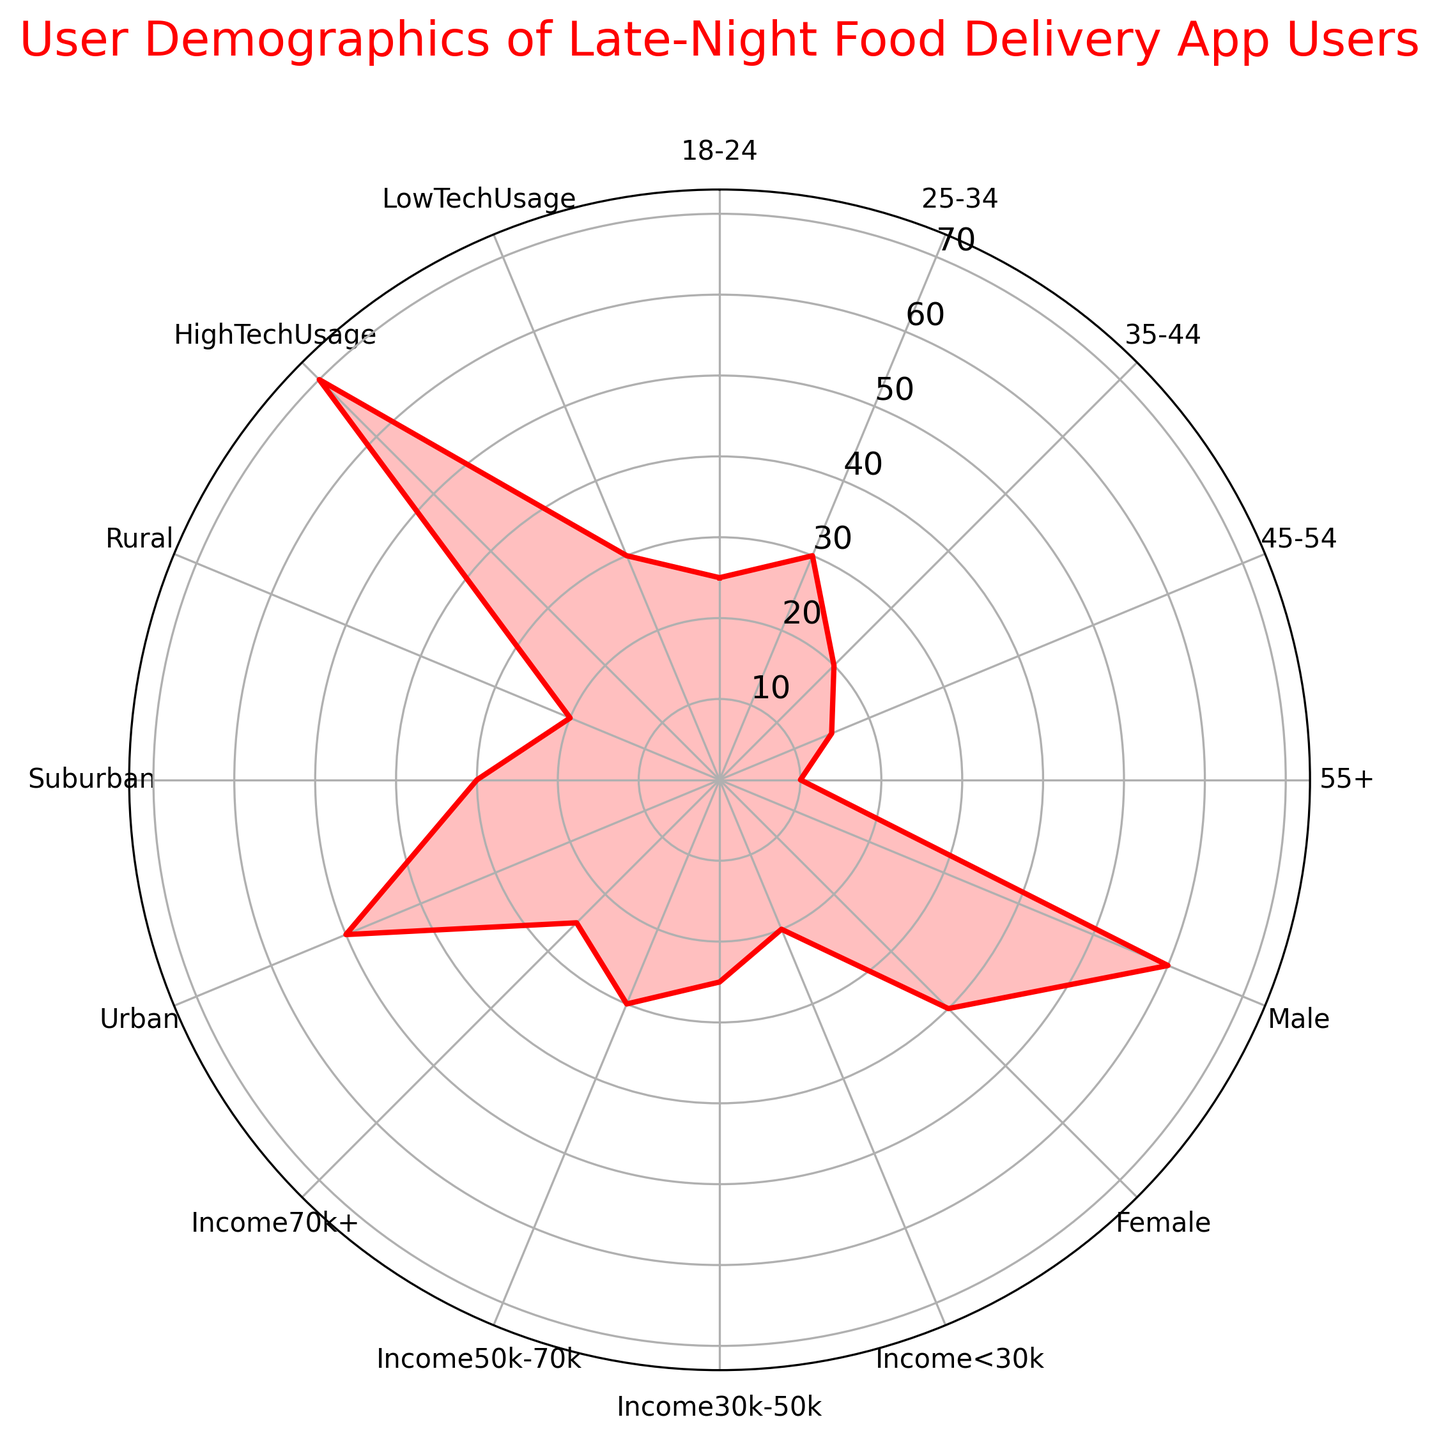Which age group has the highest percentage of users? The highest percentage values are represented on the outermost part of the radar chart. The "25-34" age group is nearest to the edge compared to other groups.
Answer: 25-34 What is the difference in percentage between male and female users? Locate the percentages for "Male" and "Female" on the radar chart. Subtract the percentage for "Female" (40) from the percentage for "Male" (60).
Answer: 20 Which income group has the least number of users? Look for the segment closest to the center on the radar chart considering income groups. "Income < 30k" is located closest to the center.
Answer: Income < 30k How does the percentage of urban users compare to suburban and rural users? Compare the positions on the radar chart for "Urban," "Suburban," and "Rural." "Urban" is furthest from the center, "Suburban" is in the middle, and "Rural" is closest to the center.
Answer: Urban > Suburban > Rural What is the combined percentage of 45-54 and 55+ age groups? Add the percentages for "45-54" and "55+" from the radar chart. 15 for "45-54" plus 10 for "55+."
Answer: 25 Which gender has a higher percentage of late-night food delivery app users? Compare the lengths of the sections for "Male" and "Female." The "Male" section is longer.
Answer: Male What is the difference in percentage between high technology usage and low technology usage users? Locate "HighTechUsage" and "LowTechUsage" on the radar chart. Subtract the value for "LowTechUsage" (30) from "HighTechUsage" (70).
Answer: 40 Is the percentage of suburban and rural users together greater than urban users? Add the percentages for "Suburban" and "Rural" (30 + 20) and compare to "Urban" (50).
Answer: No What is the average percentage of the age groups 35-44 and 45-54? Calculate the mean by adding the percentages for "35-44" and "45-54" (20 + 15) and then dividing by 2.
Answer: 17.5 Which group has a higher percentage: Income 30k-50k or Income 50k-70k? Compare the lengths of the sections for "Income 30k-50k" and "Income 50k-70k." The section for "Income 50k-70k" is longer.
Answer: Income 50k-70k 